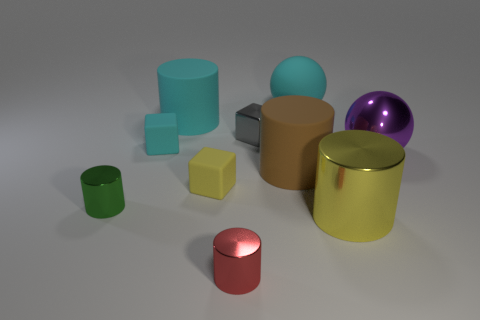What number of other things are the same shape as the big brown rubber thing? There are two items that share the same cylindrical shape as the large brown object; one is significantly smaller and red, while the other is a medium-sized green item. 